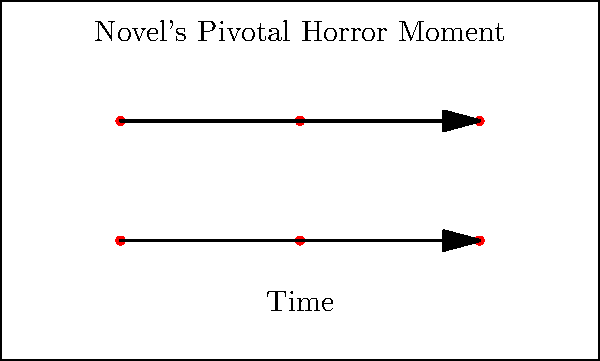In creating a storyboard for a novel's pivotal horror moment, which element should be emphasized to build tension and atmosphere in the visual representation? To create an effective storyboard for a novel's pivotal horror moment, consider the following steps:

1. Identify the key scene: Choose the most intense or critical moment from the novel.

2. Break down the scene: Divide the scene into crucial visual beats or moments.

3. Emphasize lighting: Use dramatic shadows and contrasts to create a foreboding atmosphere.

4. Focus on character reactions: Show close-ups of characters' facial expressions to convey fear and tension.

5. Utilize composition: Frame shots to create a sense of unease or claustrophobia.

6. Incorporate symbolism: Include visual elements that represent themes from the novel.

7. Show progression: Illustrate how tension builds over time through a series of panels.

8. Add sound cues: Include notes for potential sound effects or music to enhance the atmosphere.

The most critical element to emphasize in this context is lighting. Effective use of light and shadow can dramatically increase the tension and atmosphere in a horror scene, making it the key factor in translating the novel's horror onto a visual medium.
Answer: Lighting 